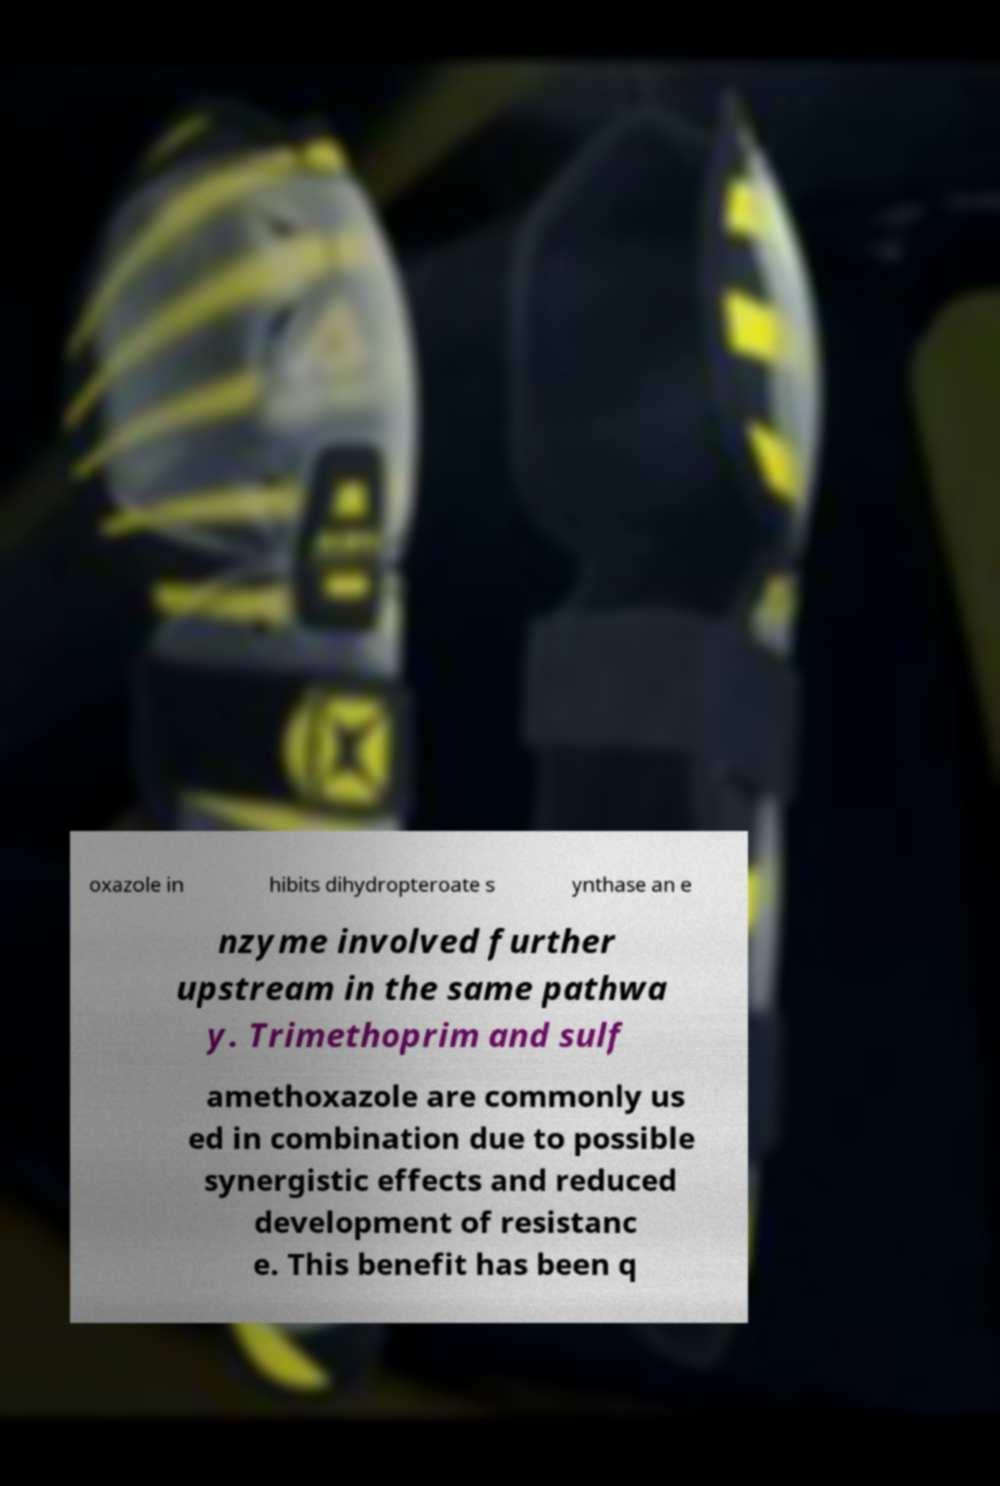Please read and relay the text visible in this image. What does it say? oxazole in hibits dihydropteroate s ynthase an e nzyme involved further upstream in the same pathwa y. Trimethoprim and sulf amethoxazole are commonly us ed in combination due to possible synergistic effects and reduced development of resistanc e. This benefit has been q 